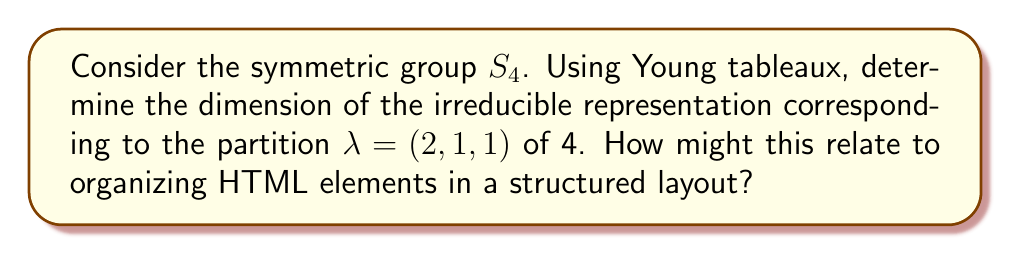Solve this math problem. To solve this problem, we'll follow these steps:

1) First, let's recall that for the symmetric group $S_n$, the irreducible representations correspond to partitions of $n$. In this case, we're dealing with $S_4$ and the partition $\lambda = (2,1,1)$.

2) The dimension of an irreducible representation of $S_n$ corresponding to a partition $\lambda$ is equal to the number of standard Young tableaux of shape $\lambda$.

3) A standard Young tableau is filled with the numbers 1 to $n$, increasing along each row and down each column.

4) For the partition $\lambda = (2,1,1)$, the Young diagram looks like:

   $$\yng(2,1,1)$$

5) Now, let's count the number of ways to fill this diagram to create standard Young tableaux:
   - 1 must always be in the top-left corner
   - 2 can be either in the top-right or the second row
   - If 2 is in the top-right, 3 must be in the second row and 4 in the third row
   - If 2 is in the second row, 3 can be either in the top-right or the third row
   - This gives us 3 possible standard Young tableaux:

     $$\young(12,3,4) \quad \young(13,2,4) \quad \young(14,2,3)$$

6) Therefore, the dimension of this irreducible representation is 3.

Relating to HTML structure:
This concept of organizing elements into a specific structure (like the Young tableau) is analogous to how HTML elements are nested and organized in a webpage. Just as each number in the Young tableau has a specific position that affects the overall structure, each HTML element has a specific place in the Document Object Model (DOM) that affects the layout and functionality of the webpage.
Answer: 3 